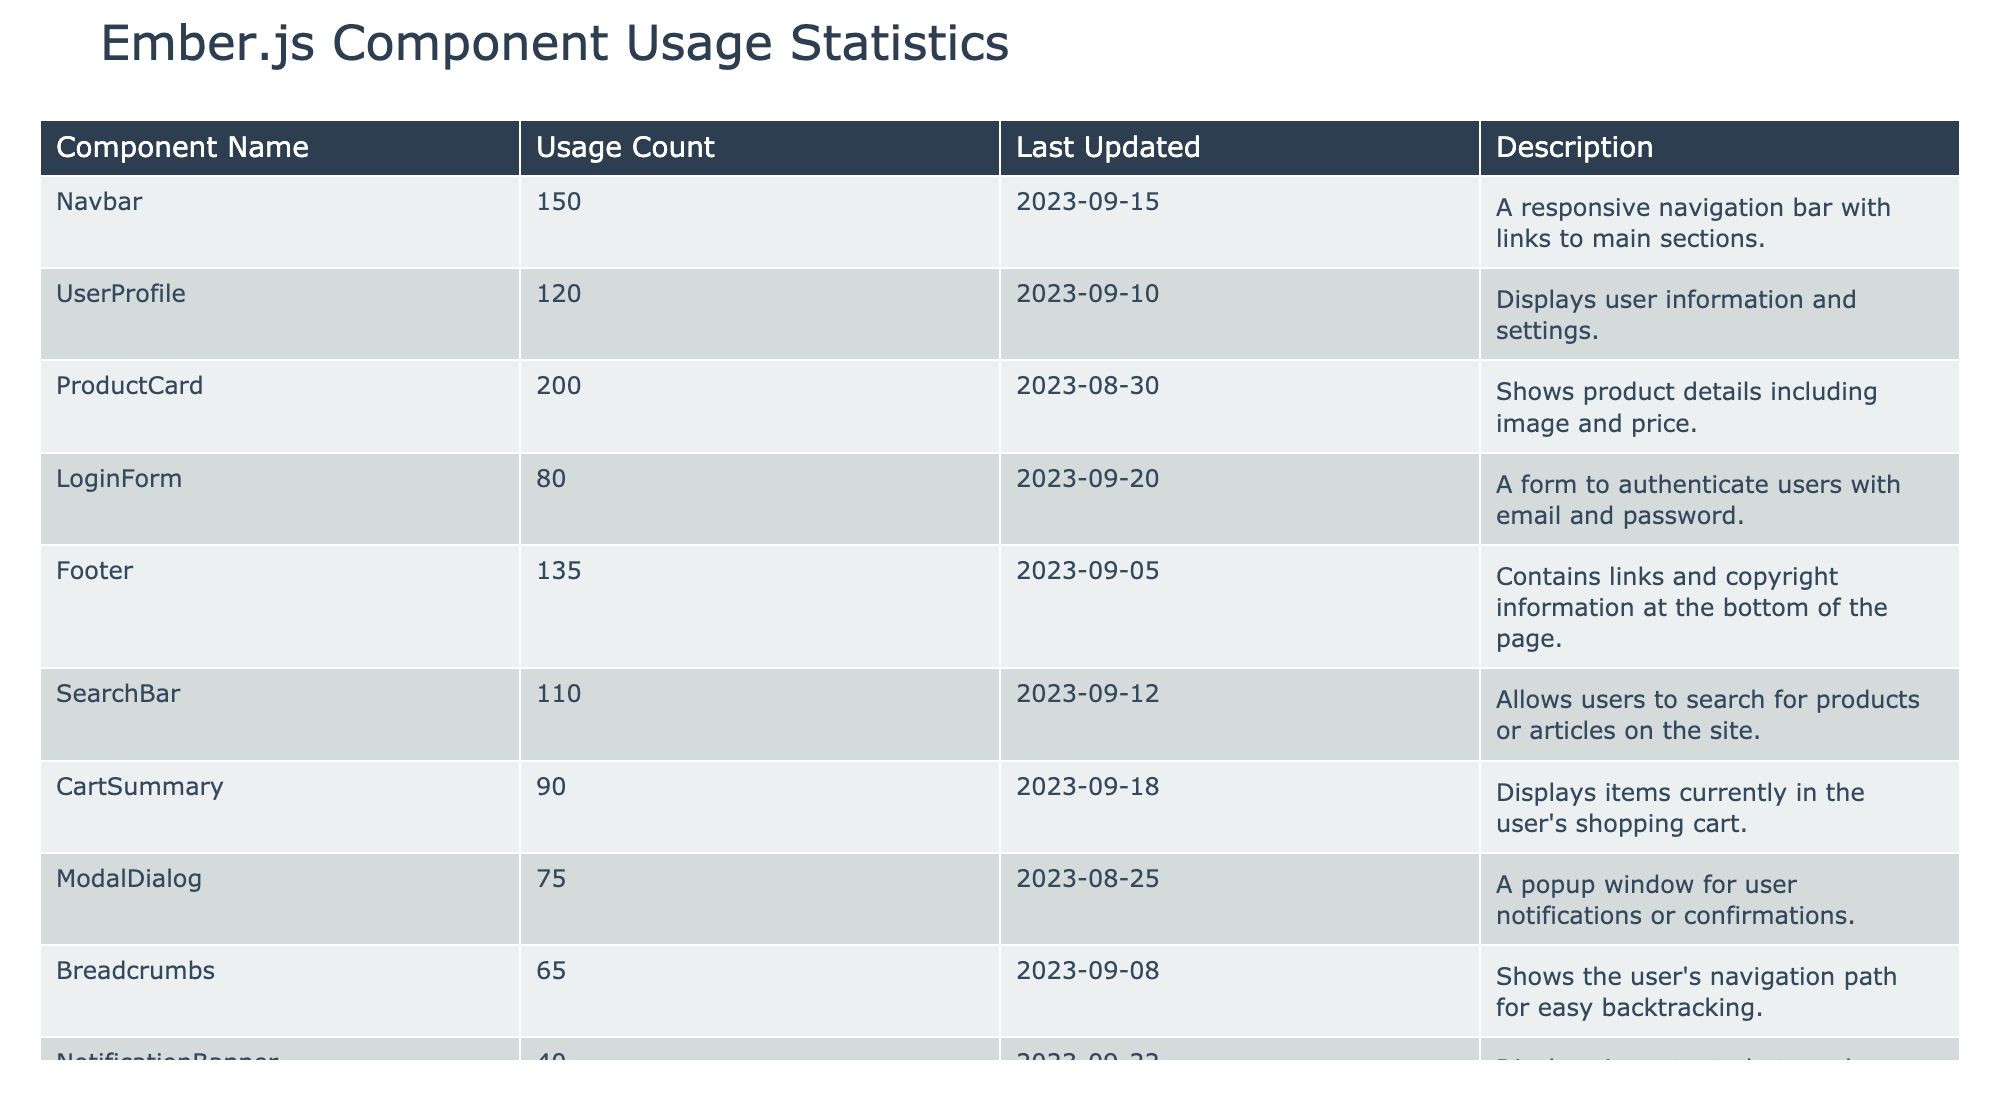What is the usage count for the ProductCard component? The ProductCard component has a usage count of 200, which can be found in the second column of the row corresponding to its name.
Answer: 200 What component was last updated on 2023-09-20? The LoginForm component was last updated on 2023-09-20, as indicated in the Last Updated column next to its name.
Answer: LoginForm Which component has the highest usage count? The ProductCard component has the highest usage count of 200, as seen in the Usage Count column, which is greater than all other components listed.
Answer: ProductCard What is the total usage count of the Navbar and Footer components? The Navbar has a usage count of 150 and the Footer has a usage count of 135. Summing these together results in 150 + 135 = 285.
Answer: 285 Is there a component that has been updated in September 2023? Yes, the LoginForm (updated on 2023-09-20), Navbar (updated on 2023-09-15), and UserProfile (updated on 2023-09-10) components were all updated in September 2023.
Answer: Yes What is the average usage count of the components listed in the table? To find the average, first sum all the usage counts: 150 + 120 + 200 + 80 + 135 + 110 + 90 + 75 + 65 + 40 = 1,100. There are 10 components, so the average is 1,100 / 10 = 110.
Answer: 110 What is the difference in usage count between the UserProfile and NotificationBanner components? The UserProfile component has a usage count of 120 and the NotificationBanner has a usage count of 40. The difference is calculated as 120 - 40 = 80.
Answer: 80 Which component has the lowest usage count? The NotificationBanner component has the lowest usage count of 40, which is the smallest value in the Usage Count column compared to all other components.
Answer: NotificationBanner Which two components were last updated most recently? The LoginForm (2023-09-20) and NotificationBanner (2023-09-22) were last updated most recently. By comparing the Last Updated dates, NotificationBanner's date comes later than all others except LoginForm.
Answer: LoginForm and NotificationBanner 